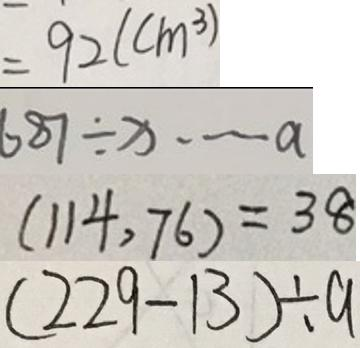<formula> <loc_0><loc_0><loc_500><loc_500>= 9 2 ( c m ^ { 3 } ) 
 6 8 7 \div x \cdots a 
 ( 1 1 4 , 7 6 ) = 3 8 
 ( 2 2 9 - 1 3 ) \div a</formula> 